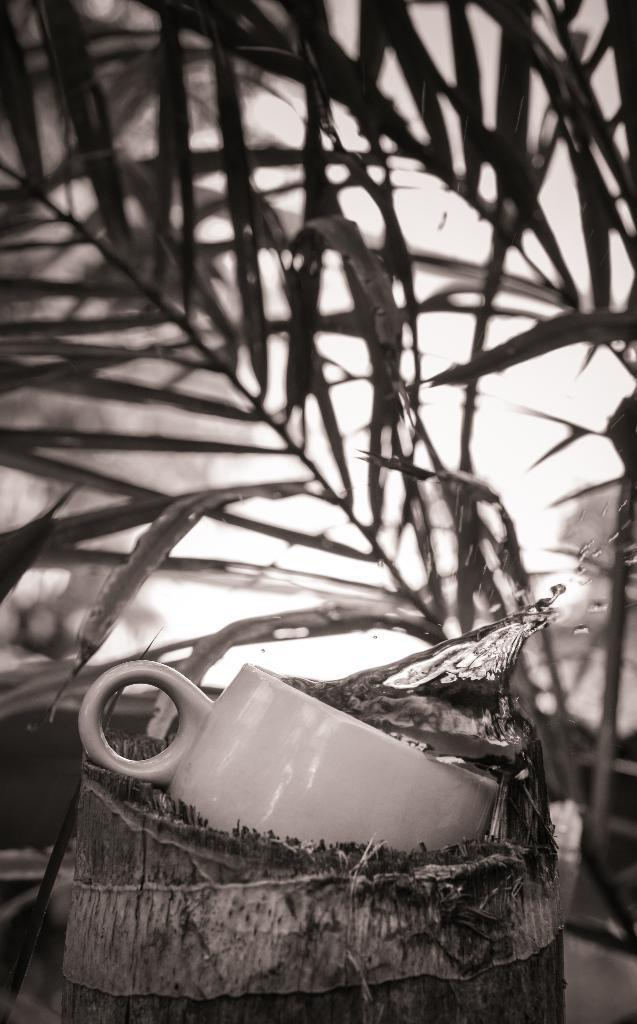What type of living organisms can be seen in the image? Plants can be seen in the image. What material is the wooden object made of? The wooden object is made of wood. What is contained within the wooden object? The wooden object contains a cup. What type of force is being applied to the quartz in the image? There is no quartz present in the image, so it is not possible to determine if any force is being applied to it. 